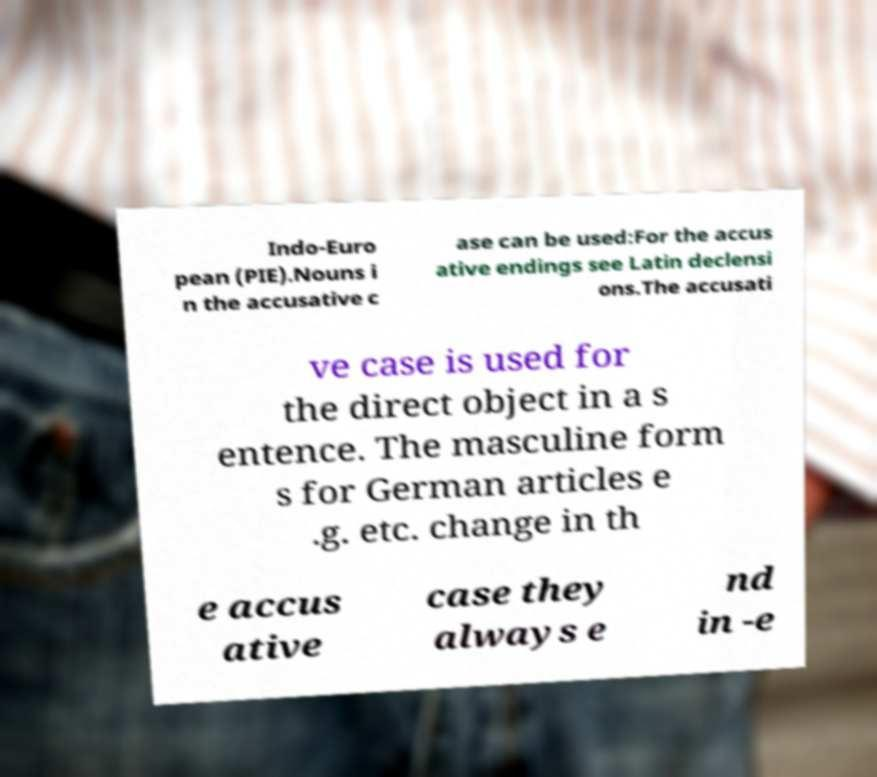Can you read and provide the text displayed in the image?This photo seems to have some interesting text. Can you extract and type it out for me? Indo-Euro pean (PIE).Nouns i n the accusative c ase can be used:For the accus ative endings see Latin declensi ons.The accusati ve case is used for the direct object in a s entence. The masculine form s for German articles e .g. etc. change in th e accus ative case they always e nd in -e 